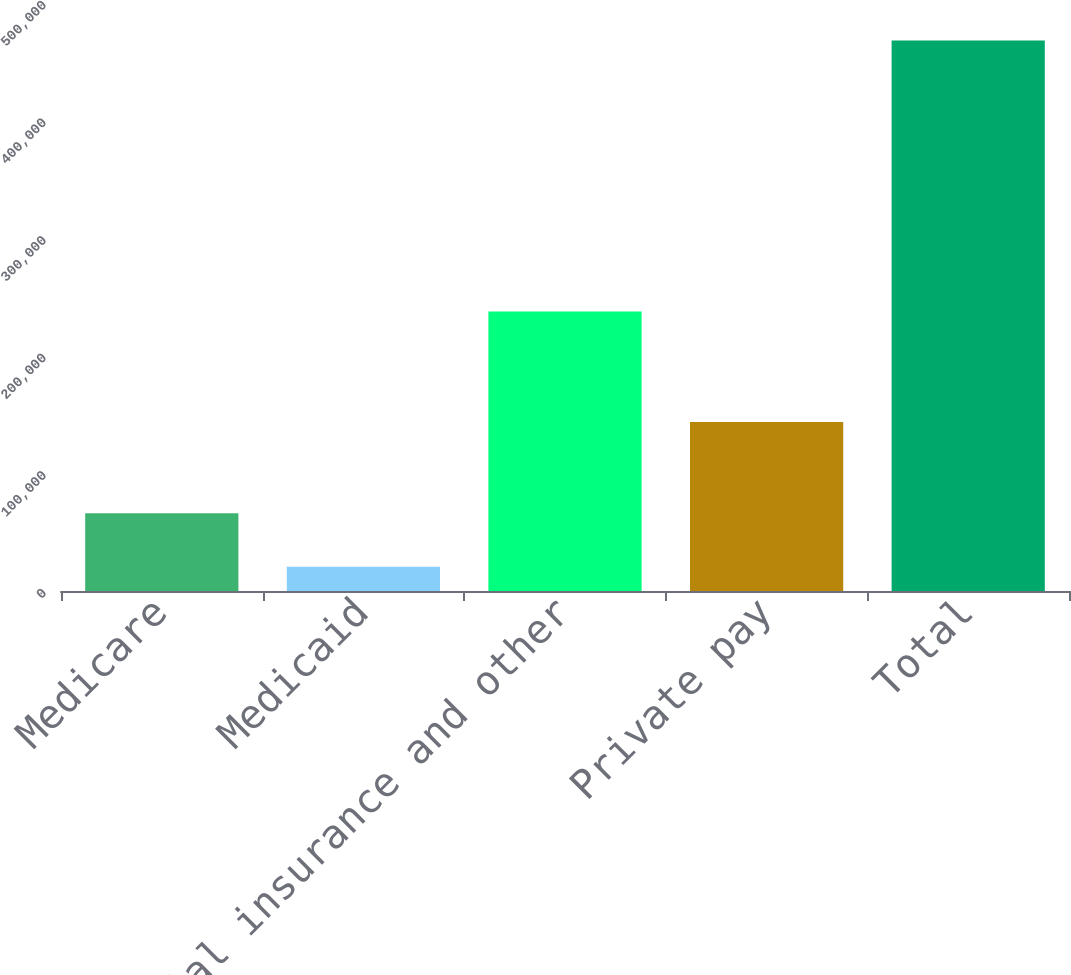Convert chart to OTSL. <chart><loc_0><loc_0><loc_500><loc_500><bar_chart><fcel>Medicare<fcel>Medicaid<fcel>Commercial insurance and other<fcel>Private pay<fcel>Total<nl><fcel>66125<fcel>20710<fcel>237587<fcel>143683<fcel>468105<nl></chart> 